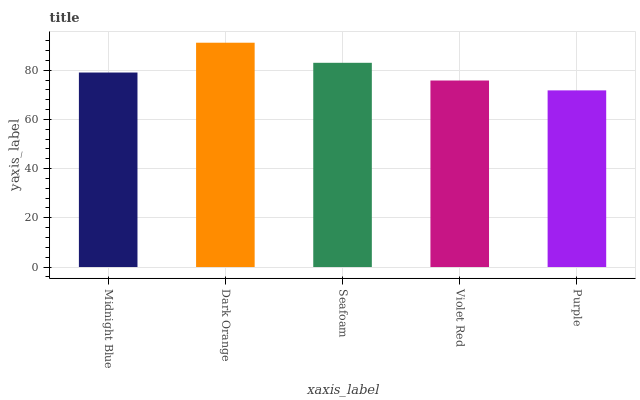Is Purple the minimum?
Answer yes or no. Yes. Is Dark Orange the maximum?
Answer yes or no. Yes. Is Seafoam the minimum?
Answer yes or no. No. Is Seafoam the maximum?
Answer yes or no. No. Is Dark Orange greater than Seafoam?
Answer yes or no. Yes. Is Seafoam less than Dark Orange?
Answer yes or no. Yes. Is Seafoam greater than Dark Orange?
Answer yes or no. No. Is Dark Orange less than Seafoam?
Answer yes or no. No. Is Midnight Blue the high median?
Answer yes or no. Yes. Is Midnight Blue the low median?
Answer yes or no. Yes. Is Violet Red the high median?
Answer yes or no. No. Is Dark Orange the low median?
Answer yes or no. No. 